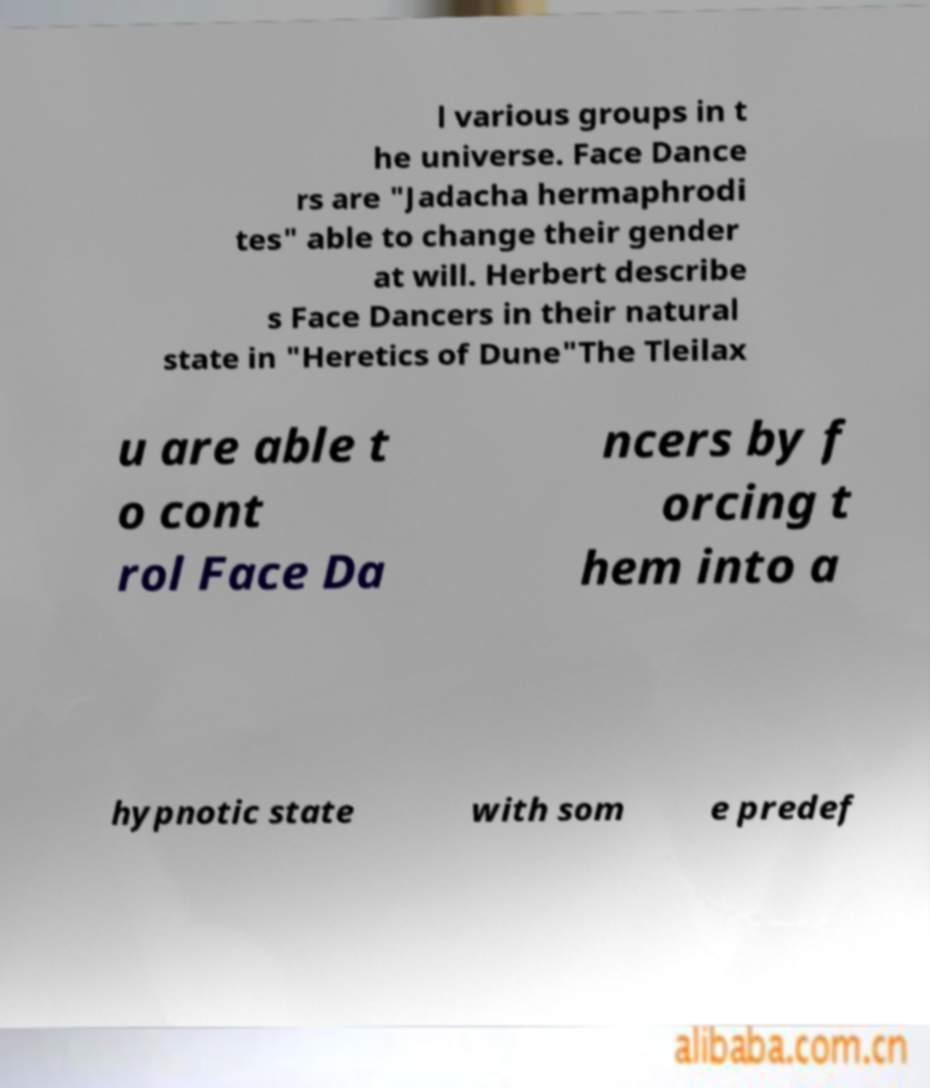Can you accurately transcribe the text from the provided image for me? l various groups in t he universe. Face Dance rs are "Jadacha hermaphrodi tes" able to change their gender at will. Herbert describe s Face Dancers in their natural state in "Heretics of Dune"The Tleilax u are able t o cont rol Face Da ncers by f orcing t hem into a hypnotic state with som e predef 